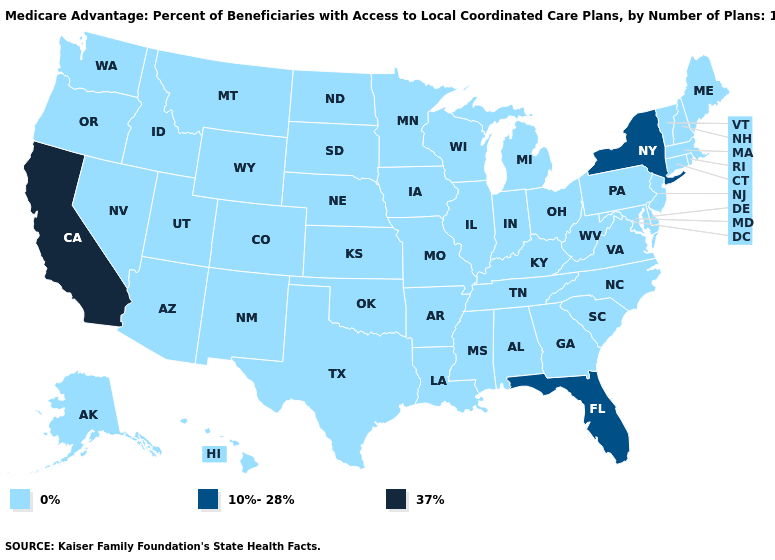Does California have the highest value in the USA?
Short answer required. Yes. Among the states that border Nevada , does Oregon have the lowest value?
Keep it brief. Yes. Name the states that have a value in the range 0%?
Give a very brief answer. Alaska, Alabama, Arkansas, Arizona, Colorado, Connecticut, Delaware, Georgia, Hawaii, Iowa, Idaho, Illinois, Indiana, Kansas, Kentucky, Louisiana, Massachusetts, Maryland, Maine, Michigan, Minnesota, Missouri, Mississippi, Montana, North Carolina, North Dakota, Nebraska, New Hampshire, New Jersey, New Mexico, Nevada, Ohio, Oklahoma, Oregon, Pennsylvania, Rhode Island, South Carolina, South Dakota, Tennessee, Texas, Utah, Virginia, Vermont, Washington, Wisconsin, West Virginia, Wyoming. Which states hav the highest value in the South?
Quick response, please. Florida. What is the value of Oklahoma?
Concise answer only. 0%. What is the value of New York?
Quick response, please. 10%-28%. What is the lowest value in states that border Alabama?
Quick response, please. 0%. What is the value of Virginia?
Quick response, please. 0%. What is the value of Arkansas?
Concise answer only. 0%. What is the lowest value in the MidWest?
Answer briefly. 0%. What is the value of South Carolina?
Concise answer only. 0%. What is the lowest value in the USA?
Keep it brief. 0%. Which states have the lowest value in the USA?
Write a very short answer. Alaska, Alabama, Arkansas, Arizona, Colorado, Connecticut, Delaware, Georgia, Hawaii, Iowa, Idaho, Illinois, Indiana, Kansas, Kentucky, Louisiana, Massachusetts, Maryland, Maine, Michigan, Minnesota, Missouri, Mississippi, Montana, North Carolina, North Dakota, Nebraska, New Hampshire, New Jersey, New Mexico, Nevada, Ohio, Oklahoma, Oregon, Pennsylvania, Rhode Island, South Carolina, South Dakota, Tennessee, Texas, Utah, Virginia, Vermont, Washington, Wisconsin, West Virginia, Wyoming. Does New York have the highest value in the Northeast?
Answer briefly. Yes. 